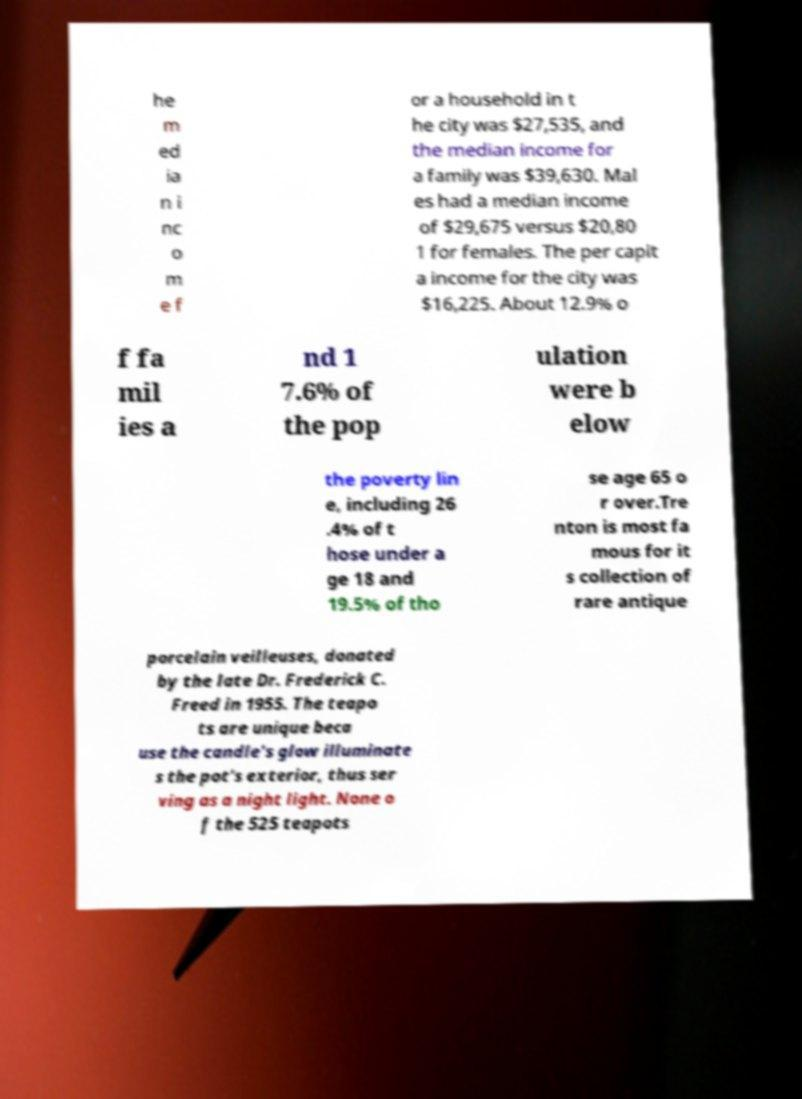There's text embedded in this image that I need extracted. Can you transcribe it verbatim? he m ed ia n i nc o m e f or a household in t he city was $27,535, and the median income for a family was $39,630. Mal es had a median income of $29,675 versus $20,80 1 for females. The per capit a income for the city was $16,225. About 12.9% o f fa mil ies a nd 1 7.6% of the pop ulation were b elow the poverty lin e, including 26 .4% of t hose under a ge 18 and 19.5% of tho se age 65 o r over.Tre nton is most fa mous for it s collection of rare antique porcelain veilleuses, donated by the late Dr. Frederick C. Freed in 1955. The teapo ts are unique beca use the candle's glow illuminate s the pot's exterior, thus ser ving as a night light. None o f the 525 teapots 